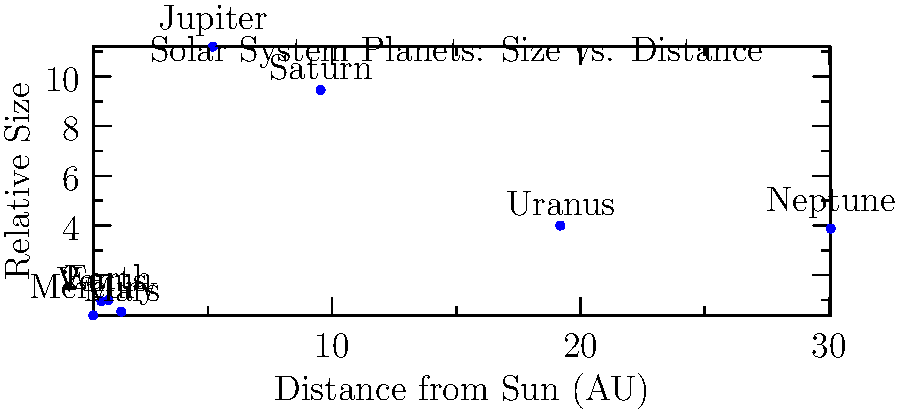In the context of a space-themed video game, you're designing a level that accurately represents the solar system. Based on the graph, which planet would be the most challenging to include in your game world due to its extreme characteristics, and why? To answer this question, let's analyze the graph step-by-step:

1. The x-axis represents the distance from the Sun in Astronomical Units (AU), while the y-axis shows the relative size of the planets.

2. Earth is used as a reference point, with a distance of 1 AU and a relative size of 1.

3. Looking at the extreme points:
   a) Jupiter stands out with the largest relative size (11.2).
   b) Neptune is the farthest from the Sun (30.07 AU).

4. From a game design perspective, the most challenging planet to include would be the one that breaks the scale of the game world the most.

5. Jupiter is significantly larger than all other planets, being over 11 times the size of Earth. This size difference would make it difficult to represent Jupiter along with the smaller planets in the same game space while maintaining proper scale.

6. Additionally, Jupiter is relatively far from the Sun (5.2 AU), which adds to the challenge of representing it accurately in relation to the inner planets.

7. While Neptune is the farthest, its size is more manageable (3.88 times Earth's size) compared to Jupiter's extreme size.

8. Representing Jupiter accurately would require either making the other planets extremely small in comparison or making Jupiter so large that it dominates the game world, potentially overshadowing other important elements of the "Clerks" inspired setting.
Answer: Jupiter, due to its extreme size and significant distance from the Sun. 